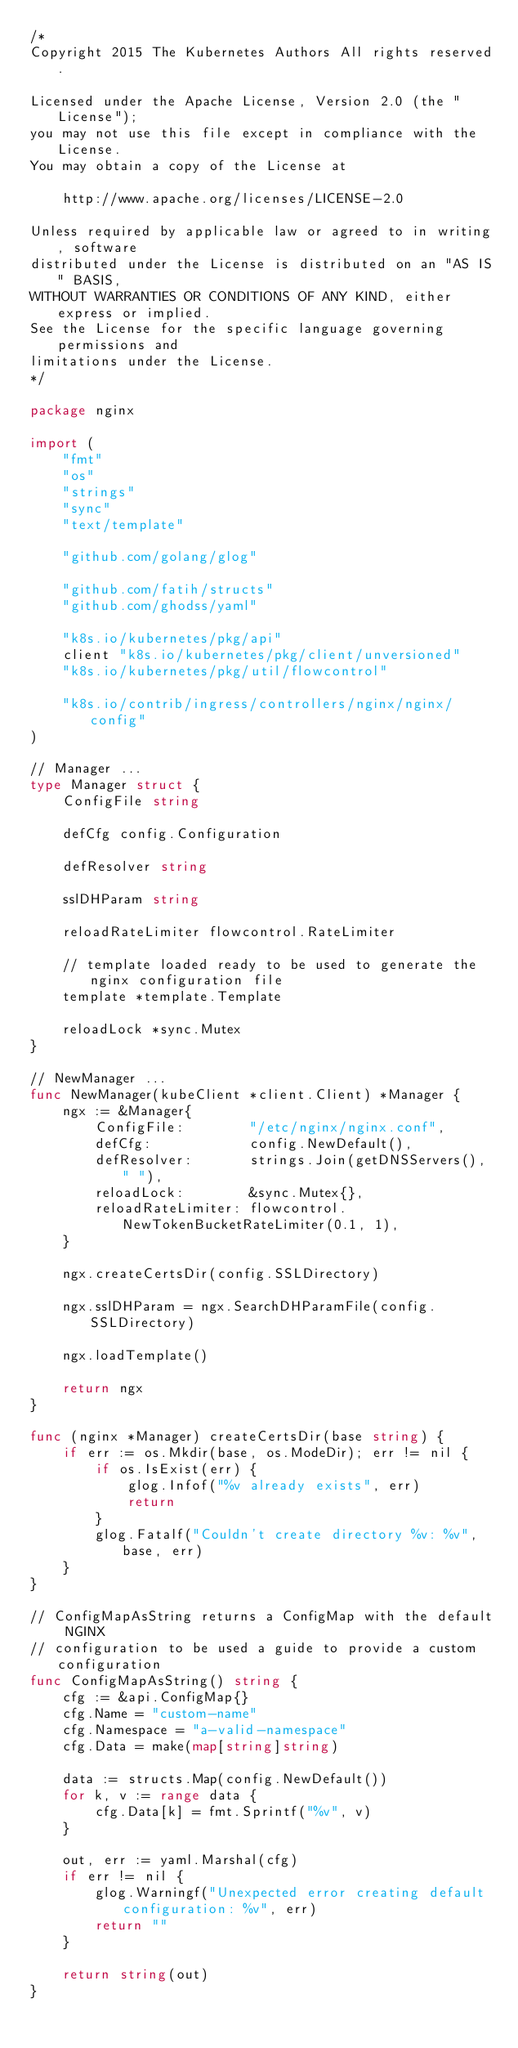Convert code to text. <code><loc_0><loc_0><loc_500><loc_500><_Go_>/*
Copyright 2015 The Kubernetes Authors All rights reserved.

Licensed under the Apache License, Version 2.0 (the "License");
you may not use this file except in compliance with the License.
You may obtain a copy of the License at

    http://www.apache.org/licenses/LICENSE-2.0

Unless required by applicable law or agreed to in writing, software
distributed under the License is distributed on an "AS IS" BASIS,
WITHOUT WARRANTIES OR CONDITIONS OF ANY KIND, either express or implied.
See the License for the specific language governing permissions and
limitations under the License.
*/

package nginx

import (
	"fmt"
	"os"
	"strings"
	"sync"
	"text/template"

	"github.com/golang/glog"

	"github.com/fatih/structs"
	"github.com/ghodss/yaml"

	"k8s.io/kubernetes/pkg/api"
	client "k8s.io/kubernetes/pkg/client/unversioned"
	"k8s.io/kubernetes/pkg/util/flowcontrol"

	"k8s.io/contrib/ingress/controllers/nginx/nginx/config"
)

// Manager ...
type Manager struct {
	ConfigFile string

	defCfg config.Configuration

	defResolver string

	sslDHParam string

	reloadRateLimiter flowcontrol.RateLimiter

	// template loaded ready to be used to generate the nginx configuration file
	template *template.Template

	reloadLock *sync.Mutex
}

// NewManager ...
func NewManager(kubeClient *client.Client) *Manager {
	ngx := &Manager{
		ConfigFile:        "/etc/nginx/nginx.conf",
		defCfg:            config.NewDefault(),
		defResolver:       strings.Join(getDNSServers(), " "),
		reloadLock:        &sync.Mutex{},
		reloadRateLimiter: flowcontrol.NewTokenBucketRateLimiter(0.1, 1),
	}

	ngx.createCertsDir(config.SSLDirectory)

	ngx.sslDHParam = ngx.SearchDHParamFile(config.SSLDirectory)

	ngx.loadTemplate()

	return ngx
}

func (nginx *Manager) createCertsDir(base string) {
	if err := os.Mkdir(base, os.ModeDir); err != nil {
		if os.IsExist(err) {
			glog.Infof("%v already exists", err)
			return
		}
		glog.Fatalf("Couldn't create directory %v: %v", base, err)
	}
}

// ConfigMapAsString returns a ConfigMap with the default NGINX
// configuration to be used a guide to provide a custom configuration
func ConfigMapAsString() string {
	cfg := &api.ConfigMap{}
	cfg.Name = "custom-name"
	cfg.Namespace = "a-valid-namespace"
	cfg.Data = make(map[string]string)

	data := structs.Map(config.NewDefault())
	for k, v := range data {
		cfg.Data[k] = fmt.Sprintf("%v", v)
	}

	out, err := yaml.Marshal(cfg)
	if err != nil {
		glog.Warningf("Unexpected error creating default configuration: %v", err)
		return ""
	}

	return string(out)
}
</code> 